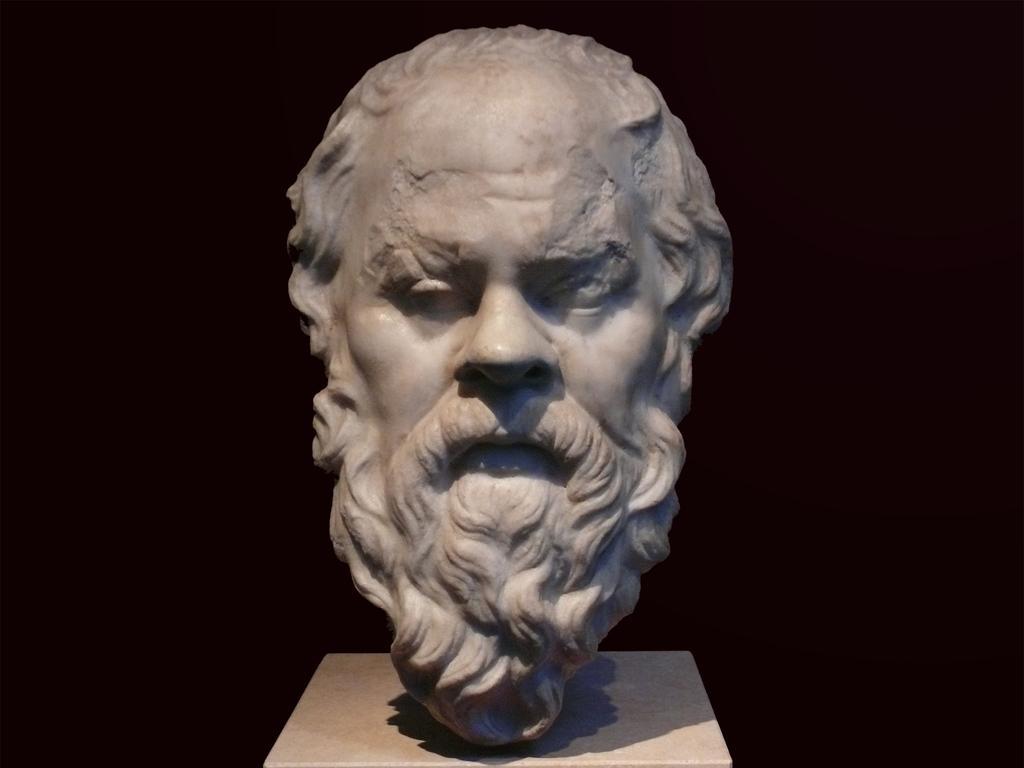Could you give a brief overview of what you see in this image? In this image there is a sculpture on a pillar. There is the face of a man on the sculpture. The background is dark. 